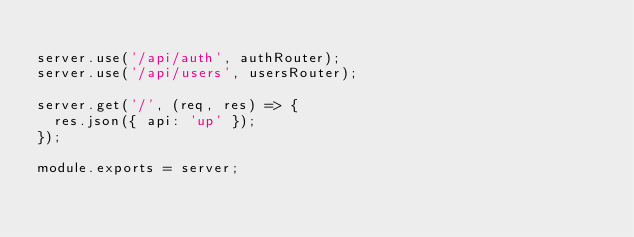Convert code to text. <code><loc_0><loc_0><loc_500><loc_500><_JavaScript_>
server.use('/api/auth', authRouter);
server.use('/api/users', usersRouter);

server.get('/', (req, res) => {
  res.json({ api: 'up' });
});

module.exports = server;
</code> 